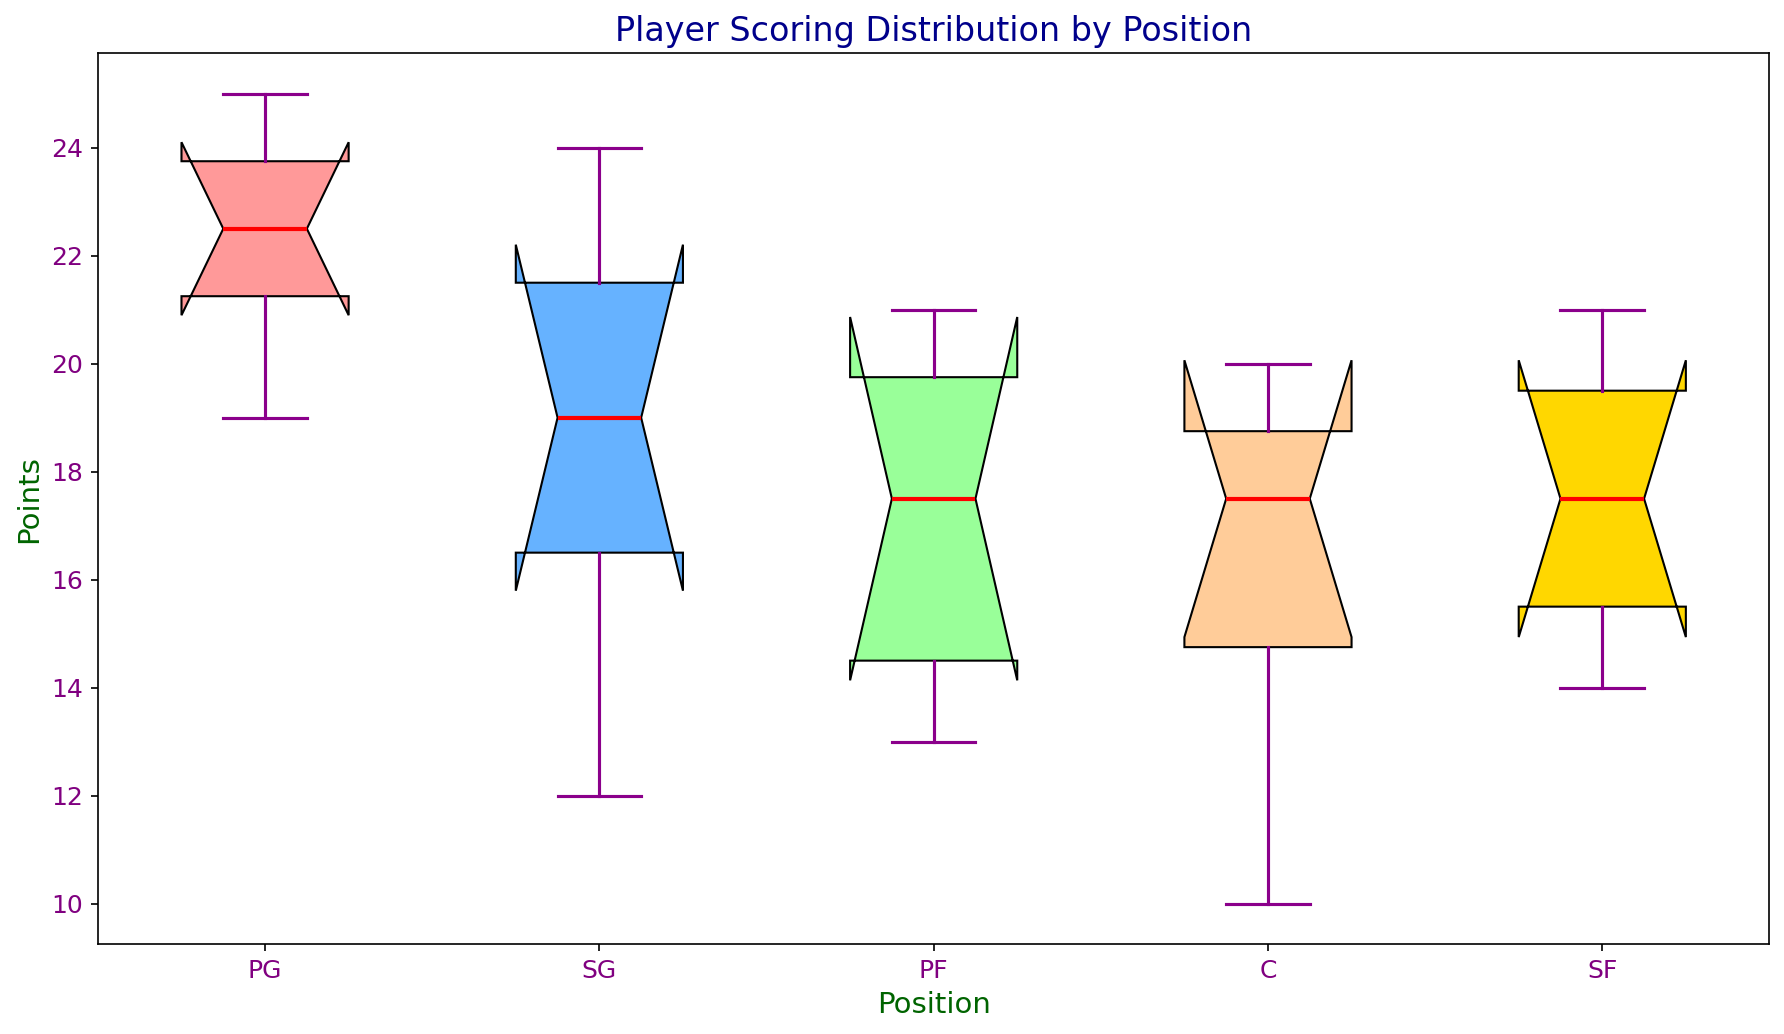What is the median scoring for Point Guards (PG)? To find the median scoring for PGs, locate the middle value in the sorted list of scores for PGs (22, 25, 23, 24, 21, 19). The sorted list is 19, 21, 22, 23, 24, 25. The median is the average of the middle two numbers, (22+23)/2.
Answer: 22.5 Which position has the highest median score? Compare the median scores of all positions. The medians are typically indicated by the red lines in the box plots. Observing the red lines in the figure, the position with the highest one is the Shooting Guard (SG).
Answer: SG Which position has the smallest range of scoring? The range is determined by the highest and lowest whisker values in the box plots. Compare the distance between the highest and lowest points of the whiskers for each position. The position with the smallest range is the Point Guard (PG).
Answer: PG How does the interquartile range (IQR) of Centers (C) compare to Power Forwards (PF)? The IQR is the distance between the bottom and top of the box. Compare these distances for both C and PF. Visually, the IQR of PF is larger than that of C.
Answer: PF is larger What is the lower quartile (Q1) for Small Forwards (SF)? The lower quartile (Q1) is the bottom of the box in the box plot. For SF, observe the bottom of the box, which determines Q1.
Answer: 15 Are there any outliers in the Shooting Guards (SG) box plot? Outliers are usually indicated by individual points outside the whiskers. Check the SG box plot for any such points. There are no points outside the whiskers for SG.
Answer: No outliers What is the maximum score for Power Forwards (PF)? The maximum score is indicated by the top whisker of the PF box plot. Identify this value visually in the figure.
Answer: 21 Between Point Guards (PG) and Centers (C), who has a higher overall scoring variability? Variability can be observed by the overall spread of the data, including the IQR and the overall range. Compare the lengths of whiskers and boxes for PG and C. PG has less spread, indicating lower variability.
Answer: C What is the upper quartile (Q3) for Centers (C)? The upper quartile (Q3) is the top of the box in the box plot. For Centers, locate the top of the box which represents Q3.
Answer: 19 Which position has the broadest interquartile range (IQR)? The IQR is visualized by the height of the box in the box plot. Compare the height of each box and identify the broadest one. The Power Forward (PF) has the broadest IQR.
Answer: PF 